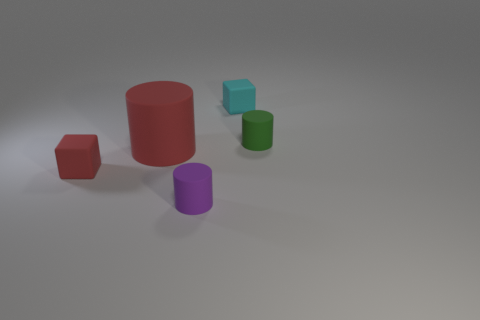Subtract all large cylinders. How many cylinders are left? 2 Add 1 small blocks. How many objects exist? 6 Subtract all cylinders. How many objects are left? 2 Add 1 tiny purple things. How many tiny purple things exist? 2 Subtract 0 brown spheres. How many objects are left? 5 Subtract all yellow cylinders. Subtract all red spheres. How many cylinders are left? 3 Subtract all big things. Subtract all big brown cylinders. How many objects are left? 4 Add 2 tiny red cubes. How many tiny red cubes are left? 3 